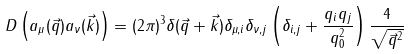<formula> <loc_0><loc_0><loc_500><loc_500>D \left ( a _ { \mu } ( \vec { q } ) a _ { \nu } ( \vec { k } ) \right ) = ( 2 \pi ) ^ { 3 } \delta ( \vec { q } + \vec { k } ) \delta _ { \mu , i } \delta _ { \nu , j } \left ( \delta _ { i , j } + \frac { q _ { i } q _ { j } } { q _ { 0 } ^ { 2 } } \right ) \frac { 4 } { \sqrt { \vec { q } ^ { 2 } } }</formula> 